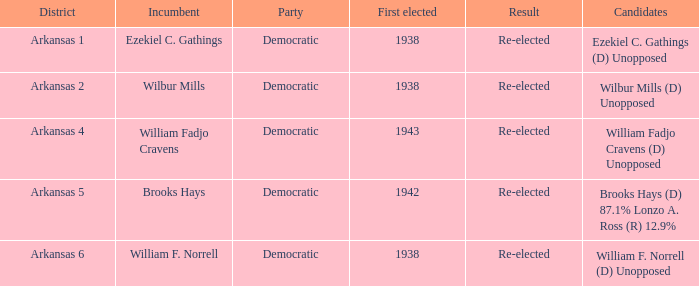What party did incumbent Brooks Hays belong to?  Democratic. 